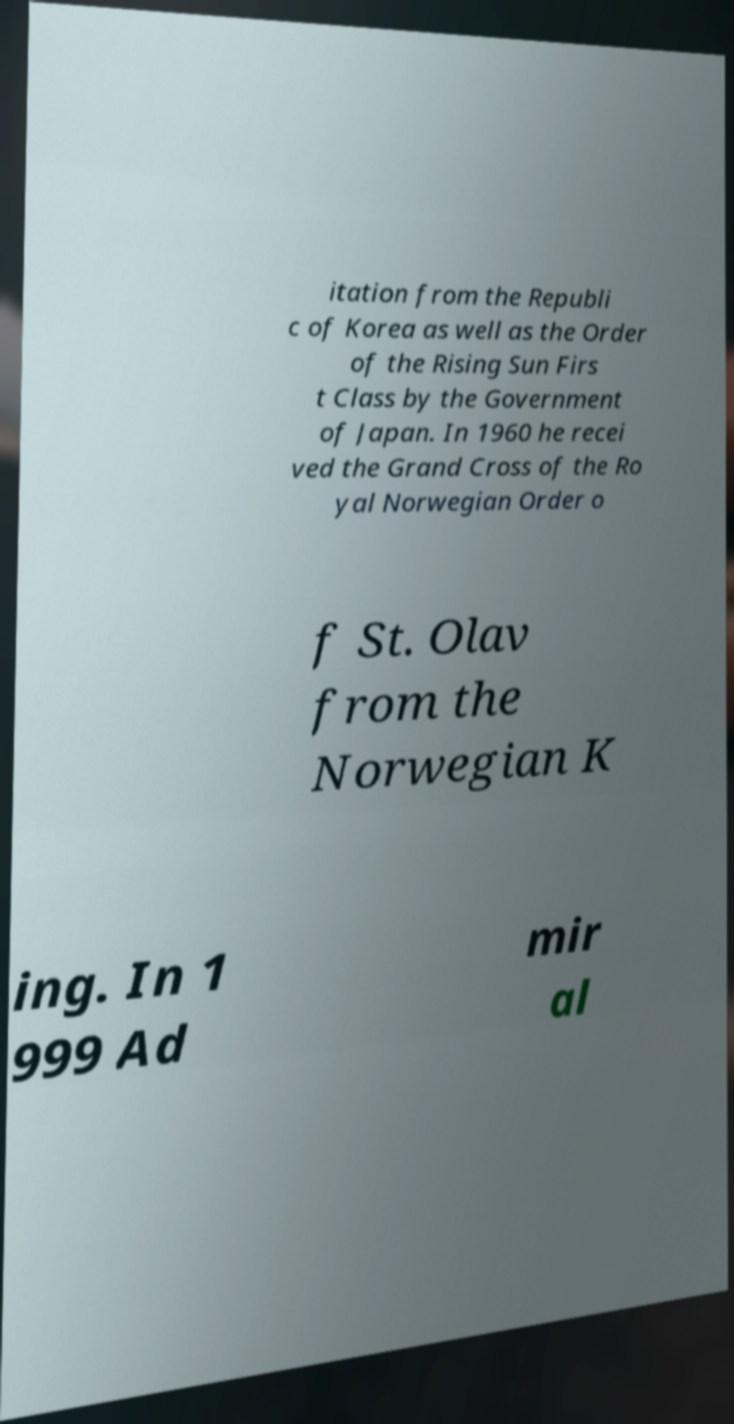Can you read and provide the text displayed in the image?This photo seems to have some interesting text. Can you extract and type it out for me? itation from the Republi c of Korea as well as the Order of the Rising Sun Firs t Class by the Government of Japan. In 1960 he recei ved the Grand Cross of the Ro yal Norwegian Order o f St. Olav from the Norwegian K ing. In 1 999 Ad mir al 